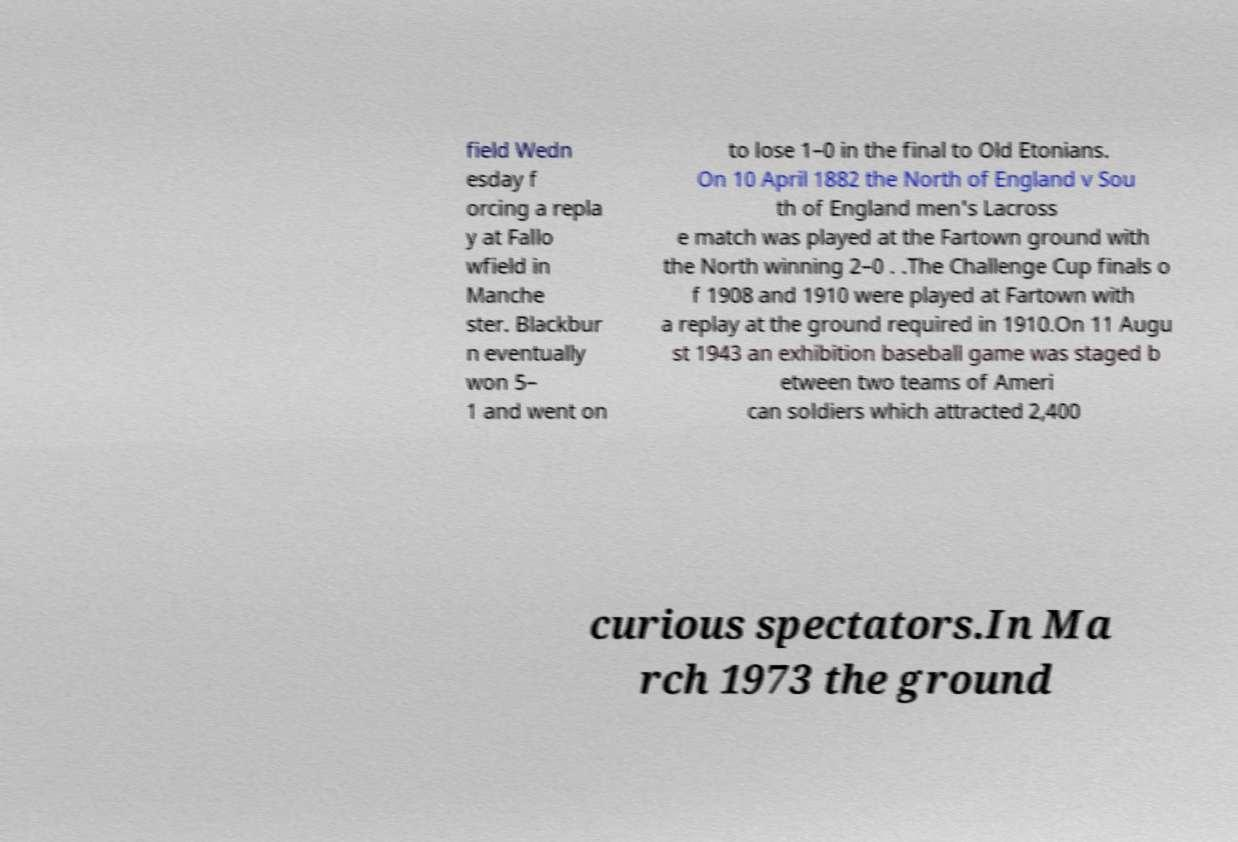There's text embedded in this image that I need extracted. Can you transcribe it verbatim? field Wedn esday f orcing a repla y at Fallo wfield in Manche ster. Blackbur n eventually won 5– 1 and went on to lose 1–0 in the final to Old Etonians. On 10 April 1882 the North of England v Sou th of England men's Lacross e match was played at the Fartown ground with the North winning 2–0 . .The Challenge Cup finals o f 1908 and 1910 were played at Fartown with a replay at the ground required in 1910.On 11 Augu st 1943 an exhibition baseball game was staged b etween two teams of Ameri can soldiers which attracted 2,400 curious spectators.In Ma rch 1973 the ground 